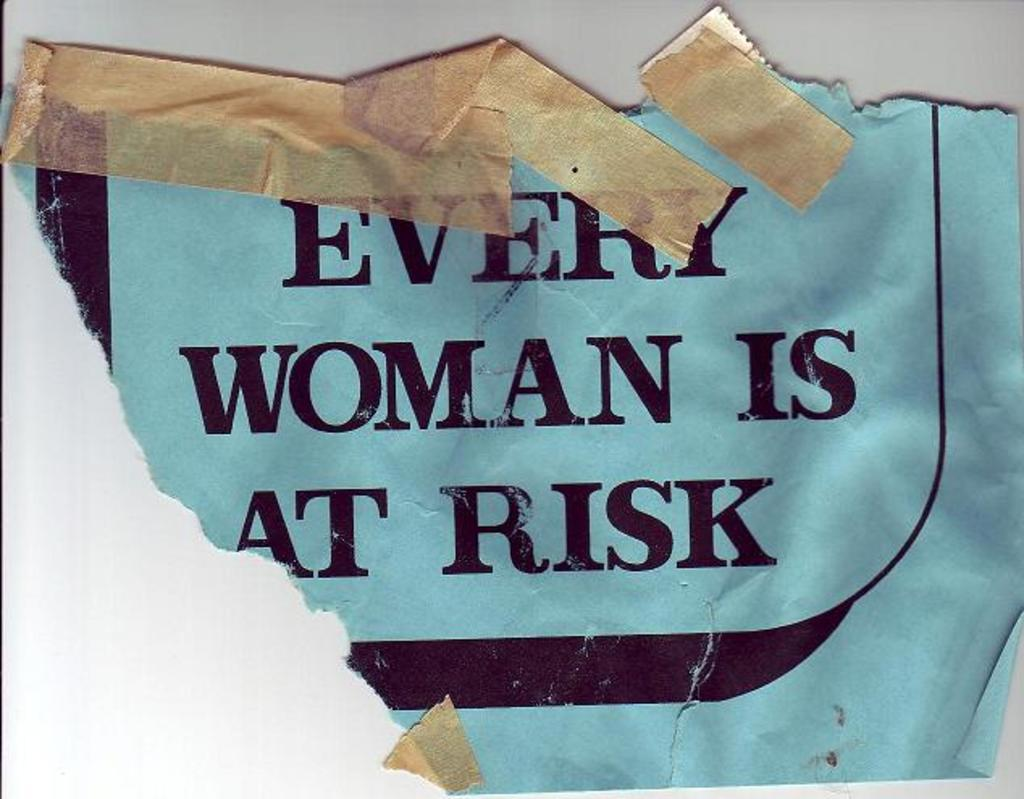What is present on the poster in the image? There is text on the poster in the image. Are there any additional elements on the poster besides the text? Yes, there are stickers stuck on the poster. Can you see a sofa in the image? There is no sofa present in the image. Is there a parcel being delivered in the image? There is no parcel or delivery depicted in the image. 